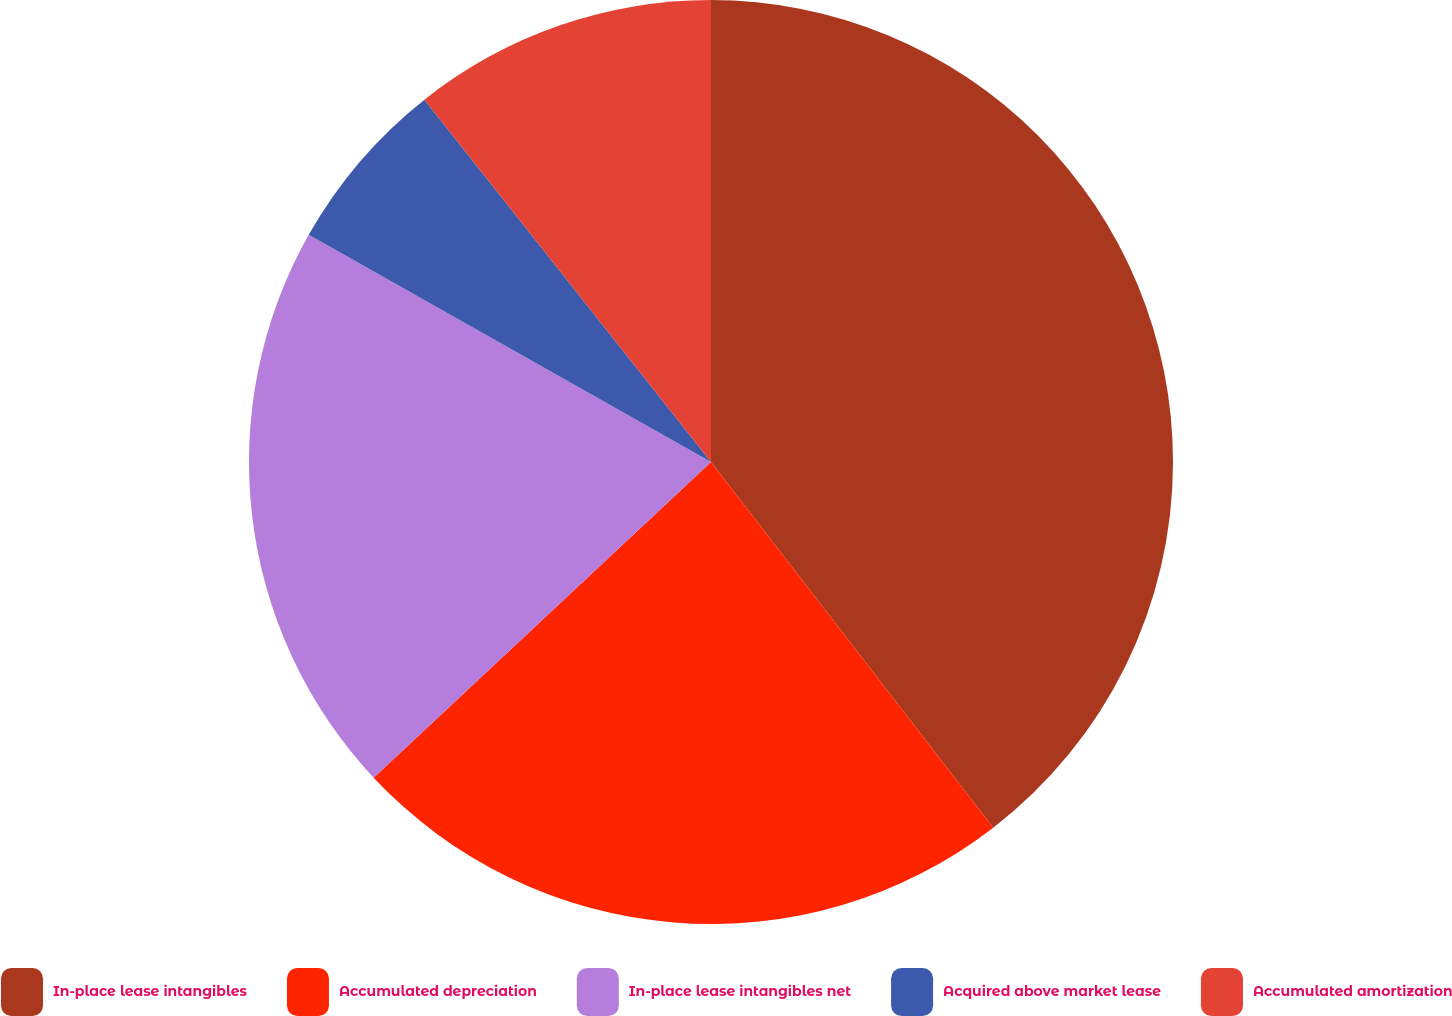Convert chart. <chart><loc_0><loc_0><loc_500><loc_500><pie_chart><fcel>In-place lease intangibles<fcel>Accumulated depreciation<fcel>In-place lease intangibles net<fcel>Acquired above market lease<fcel>Accumulated amortization<nl><fcel>39.54%<fcel>23.49%<fcel>20.15%<fcel>6.17%<fcel>10.65%<nl></chart> 